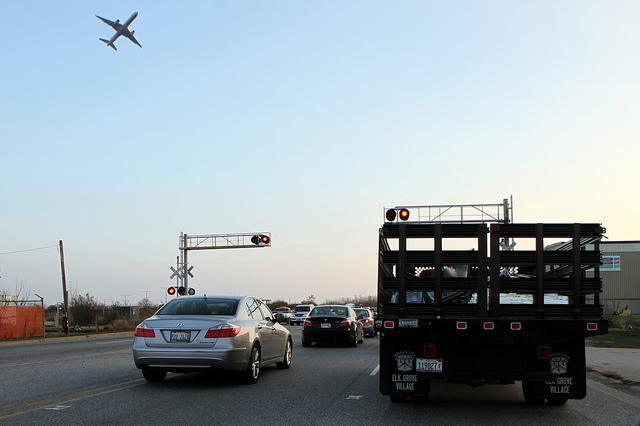Is this road wide enough for all vehicles present?
Give a very brief answer. Yes. What kind of vehicle is this?
Write a very short answer. Truck. What is in the picture?
Be succinct. Vehicles. Are the cars parked?
Answer briefly. No. What is on this truck?
Keep it brief. Supplies. Is the photo in focus?
Concise answer only. Yes. What's the thing in the sky?
Keep it brief. Plane. Is the plane landing?
Concise answer only. No. Is there a car behind the truck?
Be succinct. No. 